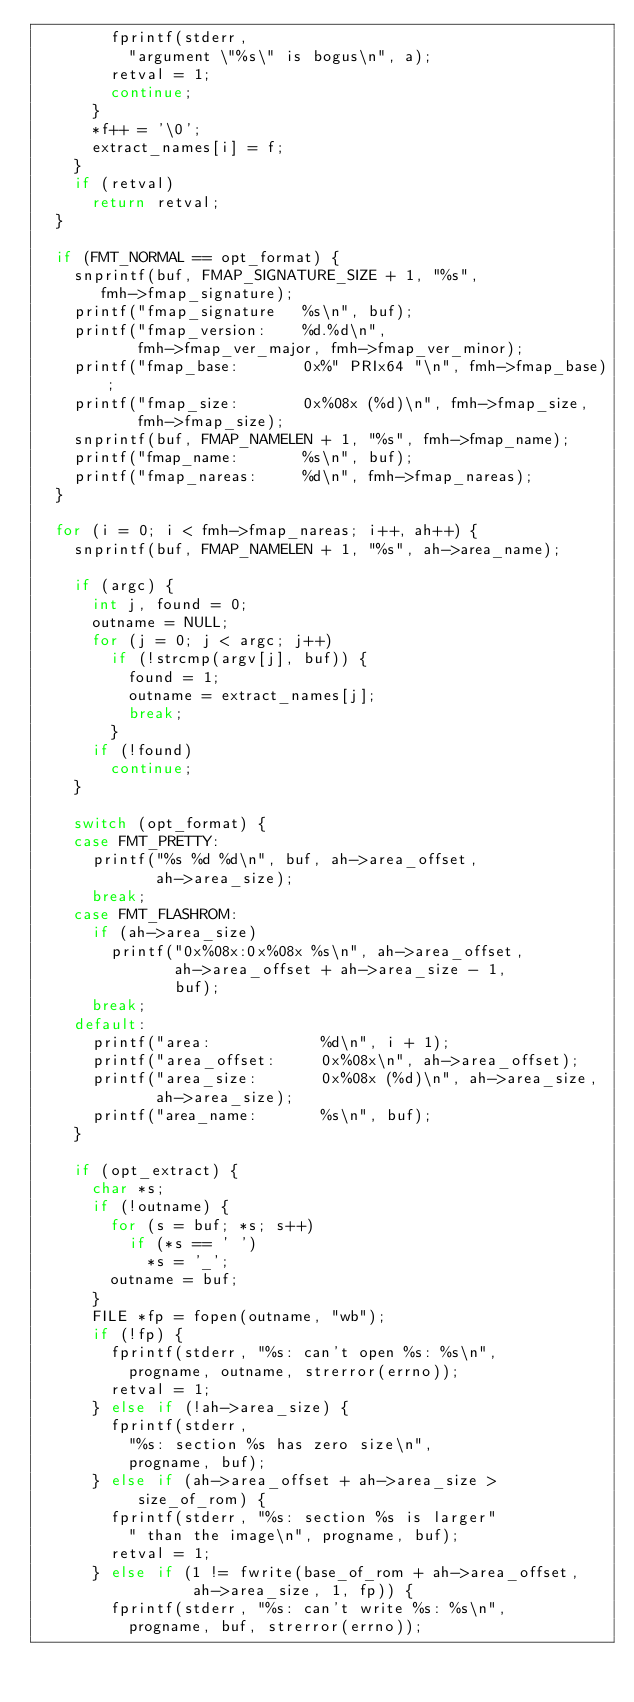Convert code to text. <code><loc_0><loc_0><loc_500><loc_500><_C_>				fprintf(stderr,
					"argument \"%s\" is bogus\n", a);
				retval = 1;
				continue;
			}
			*f++ = '\0';
			extract_names[i] = f;
		}
		if (retval)
			return retval;
	}

	if (FMT_NORMAL == opt_format) {
		snprintf(buf, FMAP_SIGNATURE_SIZE + 1, "%s",
			 fmh->fmap_signature);
		printf("fmap_signature   %s\n", buf);
		printf("fmap_version:    %d.%d\n",
		       fmh->fmap_ver_major, fmh->fmap_ver_minor);
		printf("fmap_base:       0x%" PRIx64 "\n", fmh->fmap_base);
		printf("fmap_size:       0x%08x (%d)\n", fmh->fmap_size,
		       fmh->fmap_size);
		snprintf(buf, FMAP_NAMELEN + 1, "%s", fmh->fmap_name);
		printf("fmap_name:       %s\n", buf);
		printf("fmap_nareas:     %d\n", fmh->fmap_nareas);
	}

	for (i = 0; i < fmh->fmap_nareas; i++, ah++) {
		snprintf(buf, FMAP_NAMELEN + 1, "%s", ah->area_name);

		if (argc) {
			int j, found = 0;
			outname = NULL;
			for (j = 0; j < argc; j++)
				if (!strcmp(argv[j], buf)) {
					found = 1;
					outname = extract_names[j];
					break;
				}
			if (!found)
				continue;
		}

		switch (opt_format) {
		case FMT_PRETTY:
			printf("%s %d %d\n", buf, ah->area_offset,
			       ah->area_size);
			break;
		case FMT_FLASHROM:
			if (ah->area_size)
				printf("0x%08x:0x%08x %s\n", ah->area_offset,
				       ah->area_offset + ah->area_size - 1,
				       buf);
			break;
		default:
			printf("area:            %d\n", i + 1);
			printf("area_offset:     0x%08x\n", ah->area_offset);
			printf("area_size:       0x%08x (%d)\n", ah->area_size,
			       ah->area_size);
			printf("area_name:       %s\n", buf);
		}

		if (opt_extract) {
			char *s;
			if (!outname) {
				for (s = buf; *s; s++)
					if (*s == ' ')
						*s = '_';
				outname = buf;
			}
			FILE *fp = fopen(outname, "wb");
			if (!fp) {
				fprintf(stderr, "%s: can't open %s: %s\n",
					progname, outname, strerror(errno));
				retval = 1;
			} else if (!ah->area_size) {
				fprintf(stderr,
					"%s: section %s has zero size\n",
					progname, buf);
			} else if (ah->area_offset + ah->area_size >
				   size_of_rom) {
				fprintf(stderr, "%s: section %s is larger"
					" than the image\n", progname, buf);
				retval = 1;
			} else if (1 != fwrite(base_of_rom + ah->area_offset,
					       ah->area_size, 1, fp)) {
				fprintf(stderr, "%s: can't write %s: %s\n",
					progname, buf, strerror(errno));</code> 